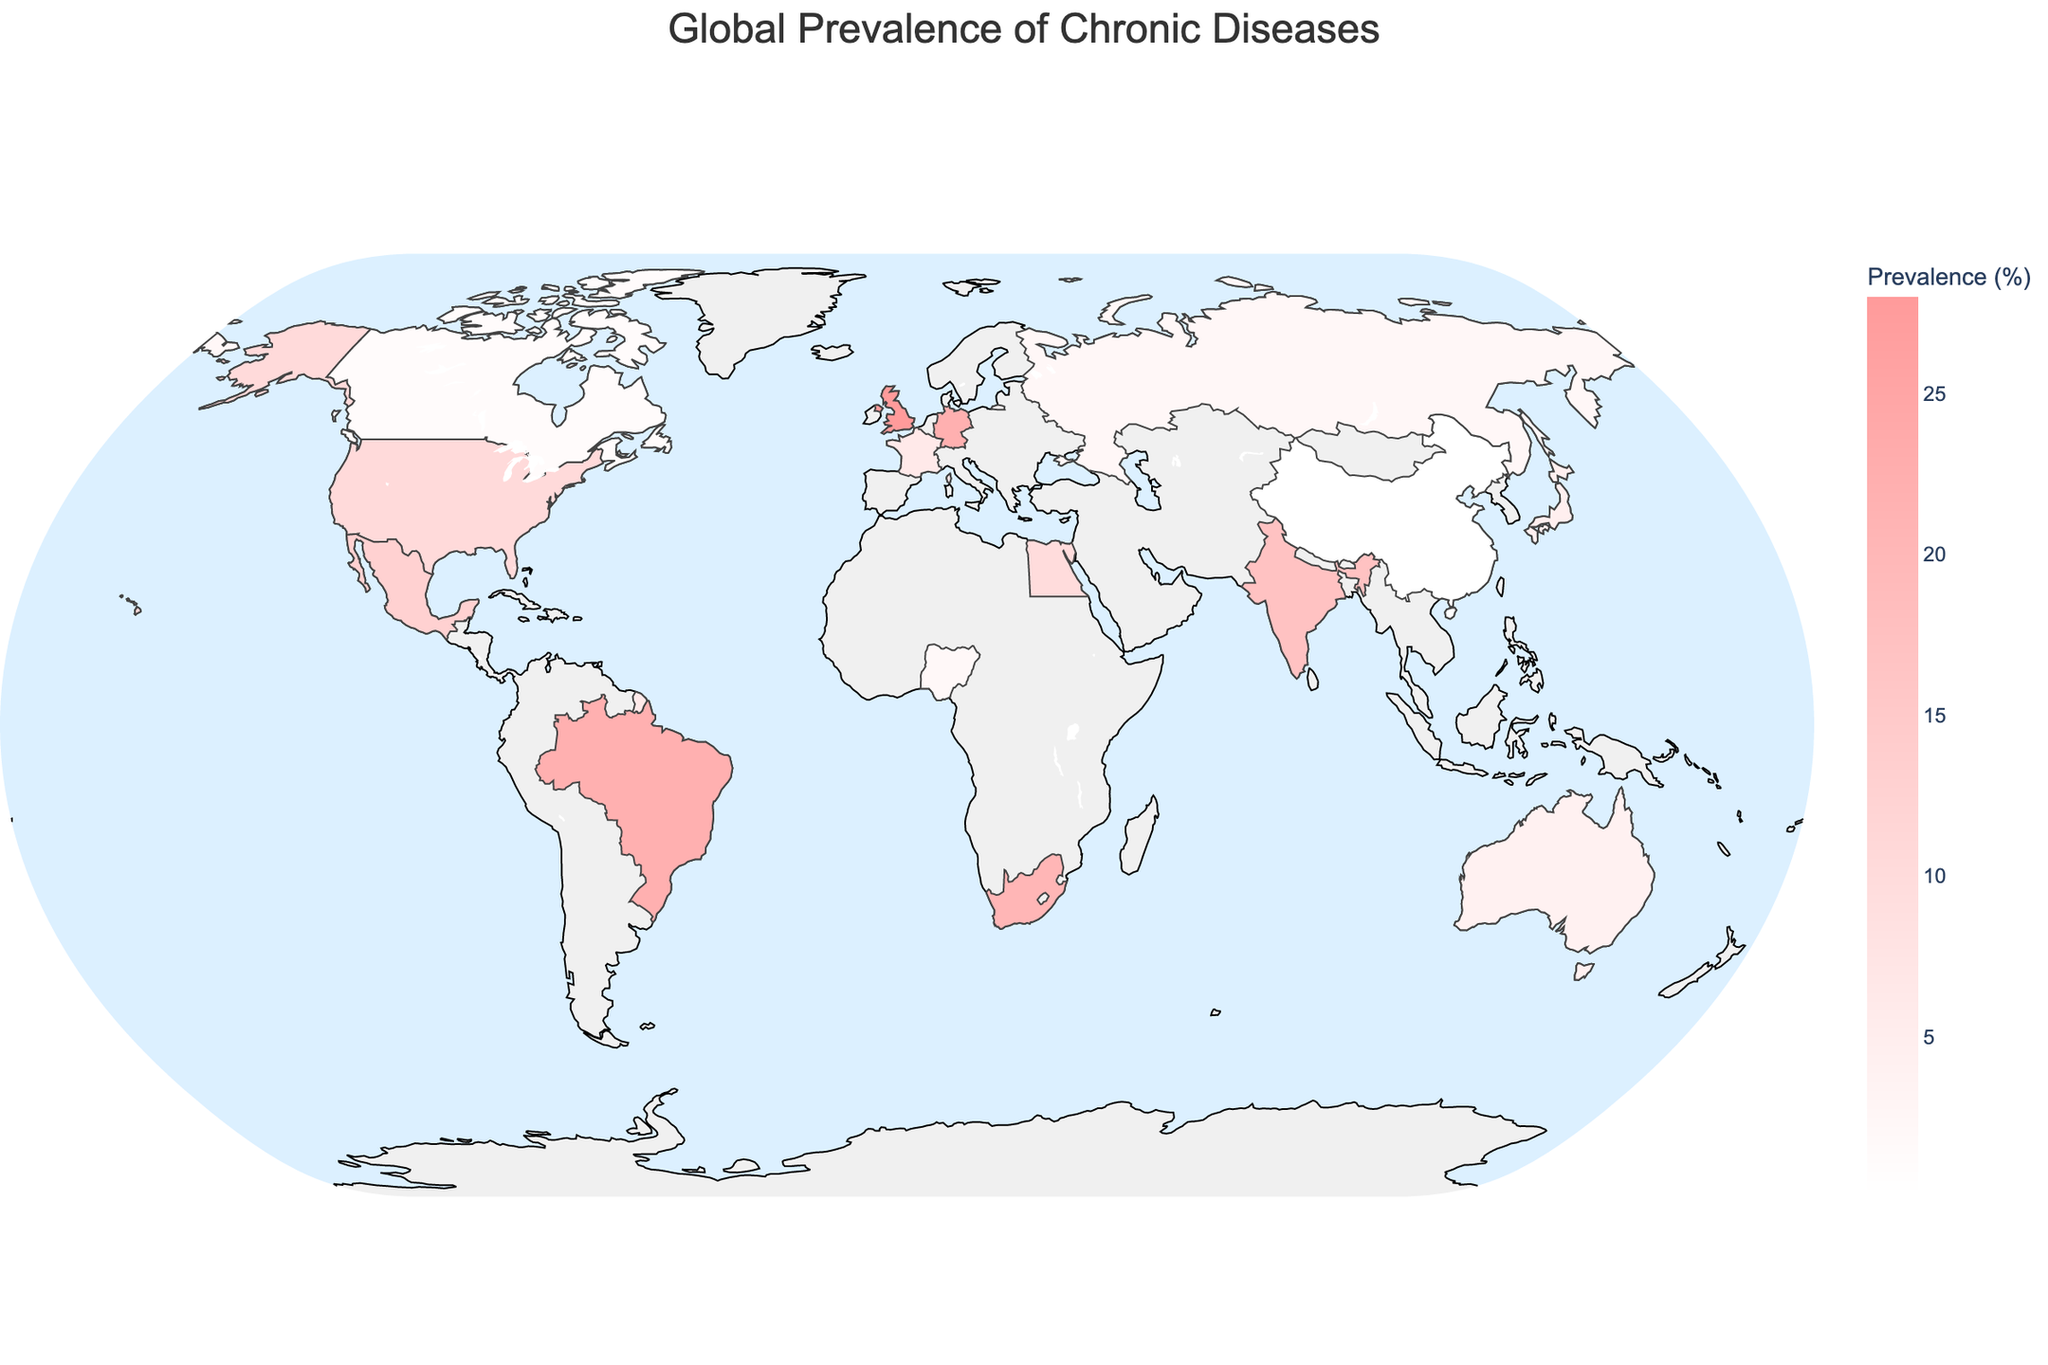What is the title of the map? The title of the figure is written prominently at the top of the map in the center.
Answer: Global Prevalence of Chronic Diseases Which region has the highest prevalence of HIV/AIDS, and what is the percentage? Locate the data points on the African continent and identify the one marked with HIV/AIDS. The prevalence is given directly on the map.
Answer: South Africa, 20.4% How do the prevalence rates of chronic respiratory diseases in Japan and cardiovascular diseases in Australia compare? Find Japan and Australia on the map and read the prevalence rates for each. Compare the two numbers directly.
Answer: Japan: 4.8%, Australia: 4.2%. Japan has a higher prevalence What is the total prevalence percentage of diabetes (both types) in North America? Identify the diabetes prevalence rates in the United States and Mexico on the map. Add these percentages together.
Answer: 10.5% (United States) + 13.1% (Mexico) = 23.6% Which country in Europe has the highest prevalence of a chronic disease, and what is the disease? Examine all European countries on the map and compare their prevalence rates. Identify the highest one and the corresponding disease.
Answer: United Kingdom, Hypertension, 28.0% Which three countries have the lowest prevalence rates, and what are their respective diseases? Scan the map for the lowest prevalence percentages and note the associated countries and diseases.
Answer: China (Cancer, 0.29%), Canada (Alzheimer's Disease, 1.5%), Nigeria (Sickle Cell Disease, 2.3%) What is the average prevalence of chronic diseases in Asia as shown on the map? Identify the Asian countries on the map (Japan, India, China) and list their prevalence rates. Calculate the average of these percentages.
Answer: (4.8% + 17.2% + 0.29%) / 3 = 7.43% Which regions have countries where no chronic disease exceeds a prevalence of 5%? Look at the prevalence of chronic diseases across different countries in each region. Identify regions where all diseases have prevalence rates below 5%.
Answer: Oceania (Australia, 4.2%), North America (Canada, 1.5%) What is the difference in the prevalence of obesity between Brazil and Germany? Locate Brazil and Germany on the map and record their prevalence rates for obesity-related chronic diseases. Subtract the smaller rate from the larger.
Answer: 22.1% (Brazil) - 22.3% (Germany) = -0.2%. Hence, Germany has a 0.2% higher prevalence Which regions are represented by more than one country on the map and what are the countries? Scan the map for regions with multiple countries listed. Note down these regions along with the countries from each.
Answer: North America (United States, Canada, Mexico), Europe (United Kingdom, Germany, France, Russia), Africa (South Africa, Egypt, Nigeria), Asia (Japan, India, China) 